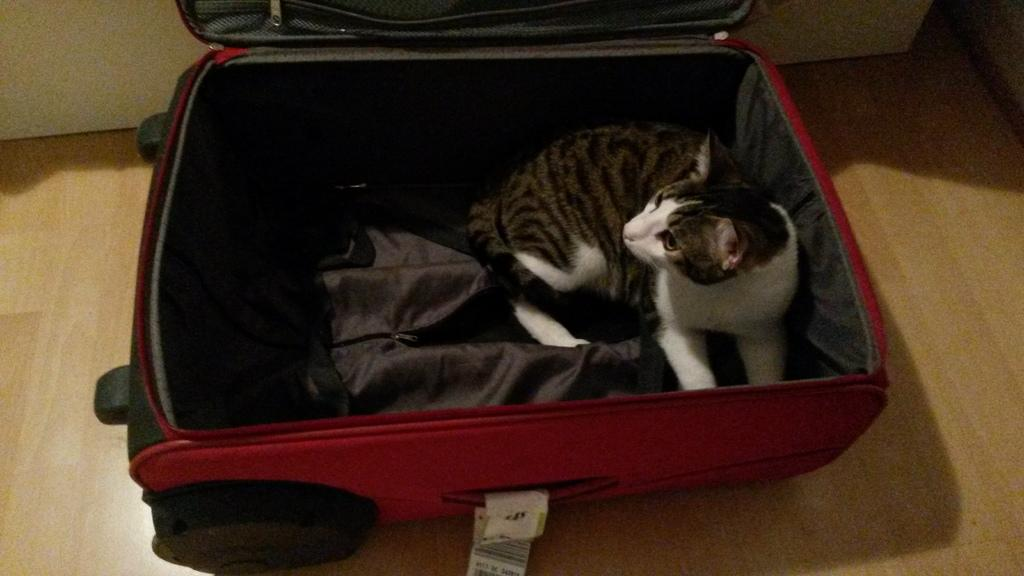What type of animal is in the image? There is a cat in the image. Where is the cat located in the image? The cat is sitting in a suitcase. What color is the suitcase? The suitcase is red in color. What type of cabbage is the cat eating in the image? There is no cabbage present in the image, and the cat is not eating anything. 